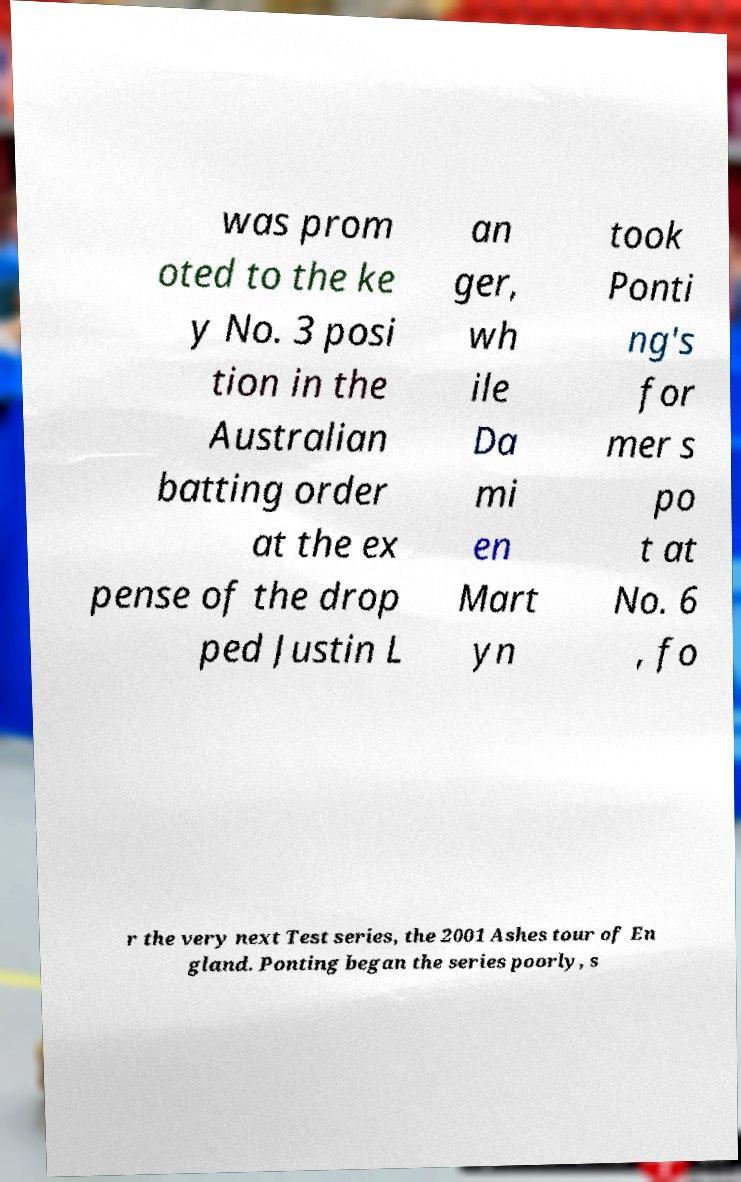I need the written content from this picture converted into text. Can you do that? was prom oted to the ke y No. 3 posi tion in the Australian batting order at the ex pense of the drop ped Justin L an ger, wh ile Da mi en Mart yn took Ponti ng's for mer s po t at No. 6 , fo r the very next Test series, the 2001 Ashes tour of En gland. Ponting began the series poorly, s 